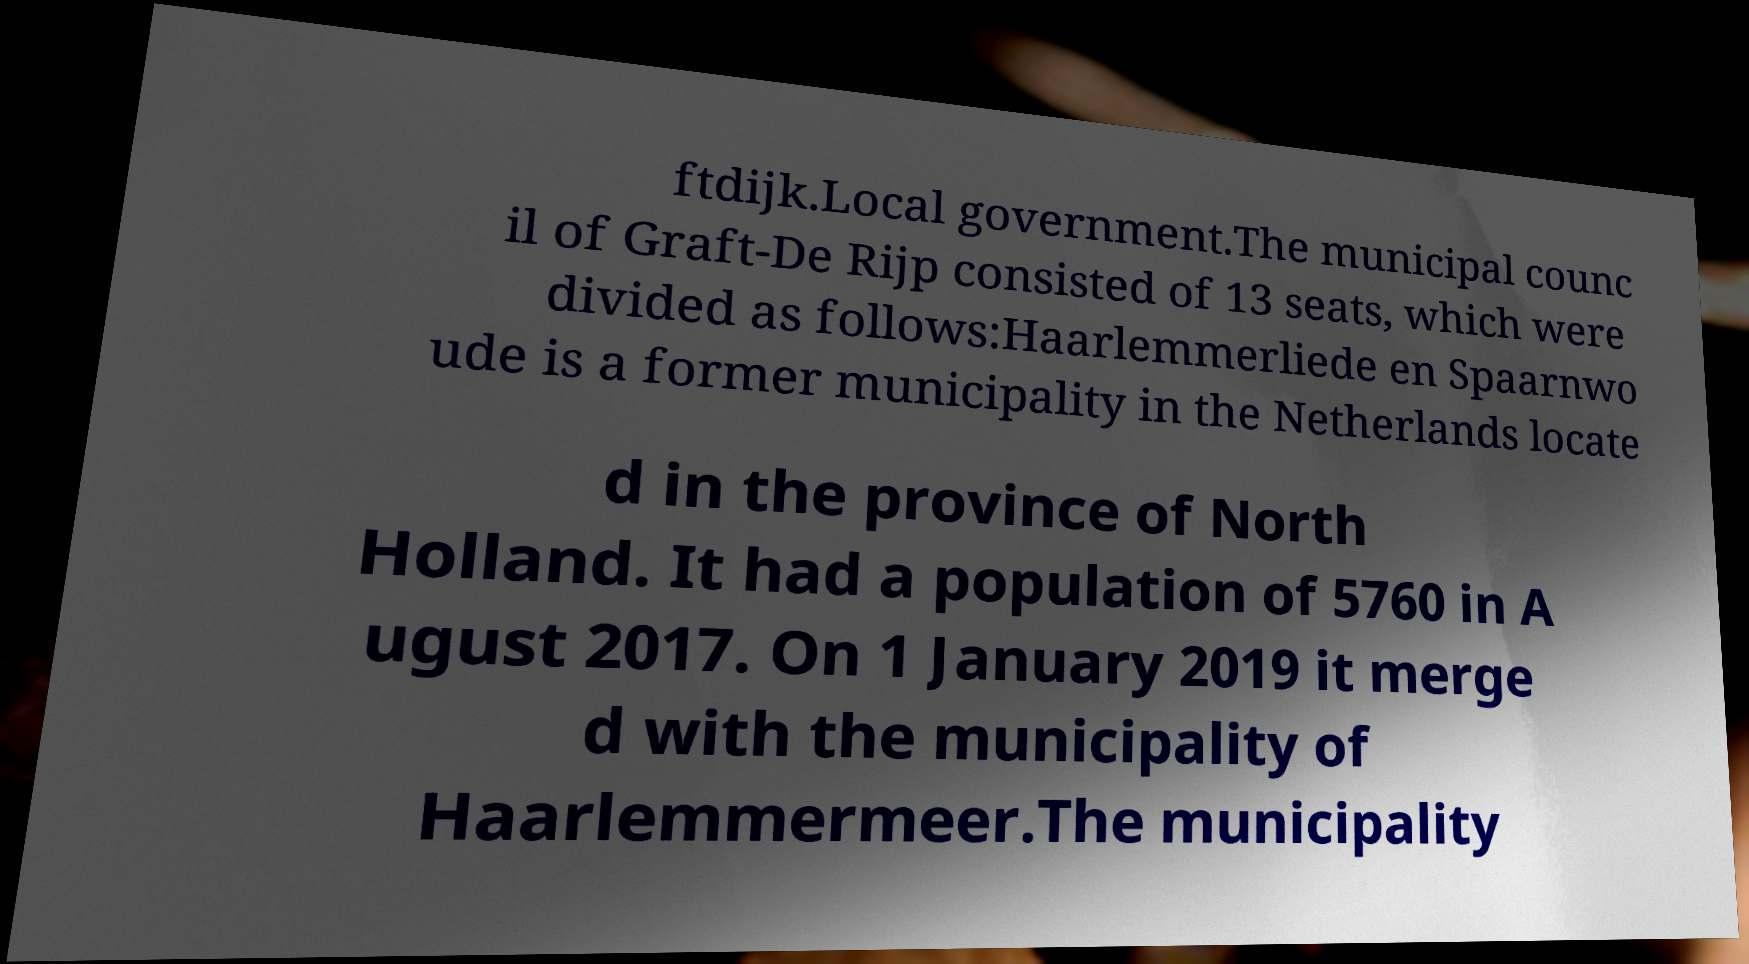Can you read and provide the text displayed in the image?This photo seems to have some interesting text. Can you extract and type it out for me? ftdijk.Local government.The municipal counc il of Graft-De Rijp consisted of 13 seats, which were divided as follows:Haarlemmerliede en Spaarnwo ude is a former municipality in the Netherlands locate d in the province of North Holland. It had a population of 5760 in A ugust 2017. On 1 January 2019 it merge d with the municipality of Haarlemmermeer.The municipality 